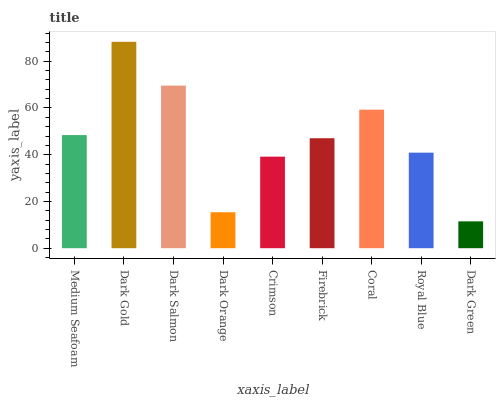Is Dark Green the minimum?
Answer yes or no. Yes. Is Dark Gold the maximum?
Answer yes or no. Yes. Is Dark Salmon the minimum?
Answer yes or no. No. Is Dark Salmon the maximum?
Answer yes or no. No. Is Dark Gold greater than Dark Salmon?
Answer yes or no. Yes. Is Dark Salmon less than Dark Gold?
Answer yes or no. Yes. Is Dark Salmon greater than Dark Gold?
Answer yes or no. No. Is Dark Gold less than Dark Salmon?
Answer yes or no. No. Is Firebrick the high median?
Answer yes or no. Yes. Is Firebrick the low median?
Answer yes or no. Yes. Is Coral the high median?
Answer yes or no. No. Is Coral the low median?
Answer yes or no. No. 